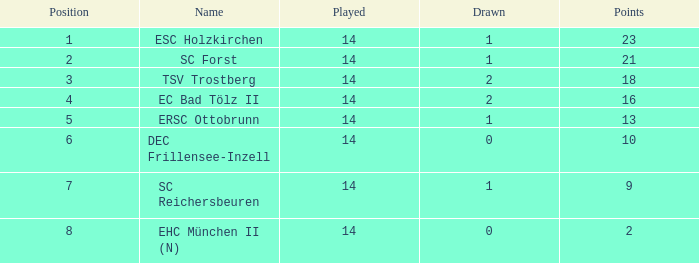Which Points have a Position larger than 6, and a Lost smaller than 13? 9.0. 